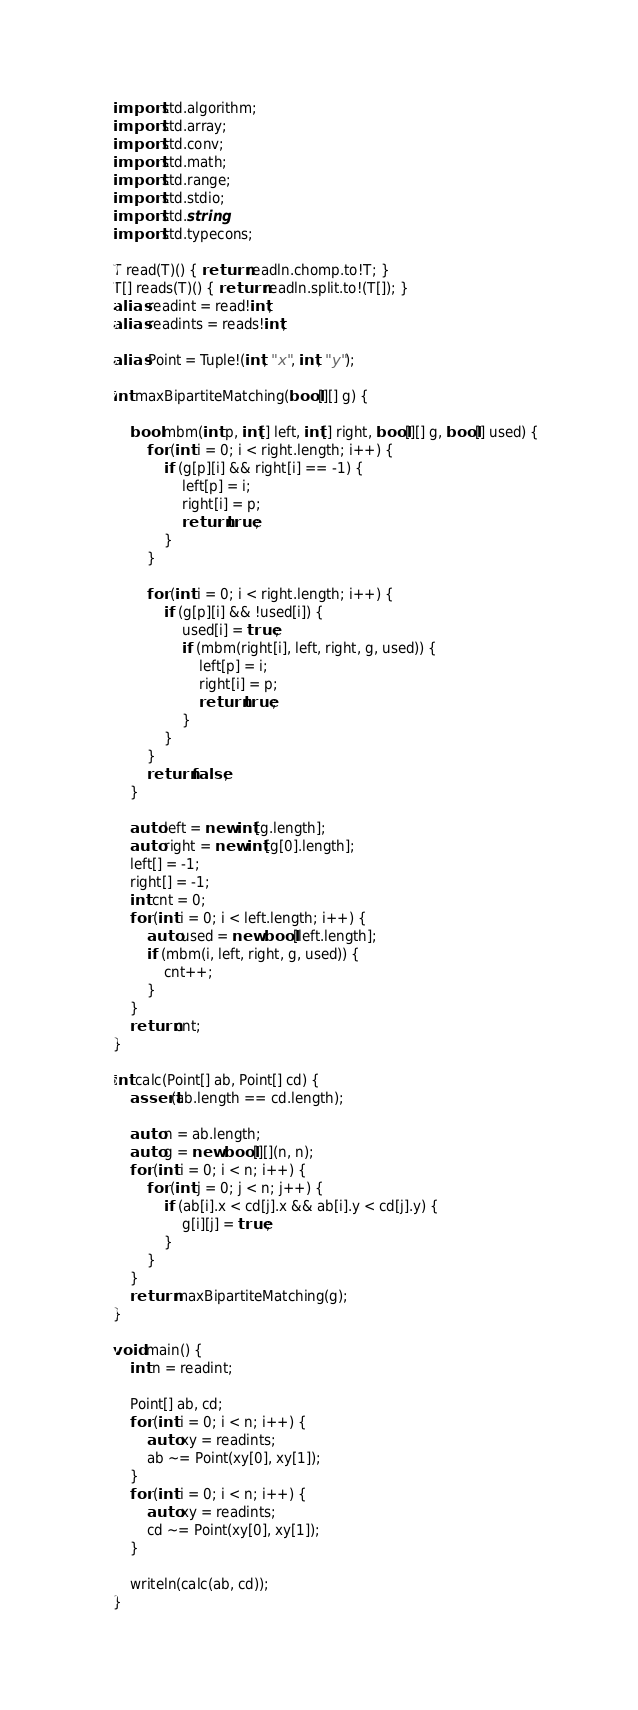Convert code to text. <code><loc_0><loc_0><loc_500><loc_500><_D_>import std.algorithm;
import std.array;
import std.conv;
import std.math;
import std.range;
import std.stdio;
import std.string;
import std.typecons;

T read(T)() { return readln.chomp.to!T; }
T[] reads(T)() { return readln.split.to!(T[]); }
alias readint = read!int;
alias readints = reads!int;

alias Point = Tuple!(int, "x", int, "y");

int maxBipartiteMatching(bool[][] g) {

    bool mbm(int p, int[] left, int[] right, bool[][] g, bool[] used) {
        for (int i = 0; i < right.length; i++) {
            if (g[p][i] && right[i] == -1) {
                left[p] = i;
                right[i] = p;
                return true;
            }
        }

        for (int i = 0; i < right.length; i++) {
            if (g[p][i] && !used[i]) {
                used[i] = true;
                if (mbm(right[i], left, right, g, used)) {
                    left[p] = i;
                    right[i] = p;
                    return true;
                }
            }
        }
        return false;
    }

    auto left = new int[g.length];
    auto right = new int[g[0].length];
    left[] = -1;
    right[] = -1;
    int cnt = 0;
    for (int i = 0; i < left.length; i++) {
        auto used = new bool[left.length];
        if (mbm(i, left, right, g, used)) {
            cnt++;
        }
    }
    return cnt;
}

int calc(Point[] ab, Point[] cd) {
    assert(ab.length == cd.length);

    auto n = ab.length;
    auto g = new bool[][](n, n);
    for (int i = 0; i < n; i++) {
        for (int j = 0; j < n; j++) {
            if (ab[i].x < cd[j].x && ab[i].y < cd[j].y) {
                g[i][j] = true;
            }
        }
    }
    return maxBipartiteMatching(g);
}

void main() {
    int n = readint;

    Point[] ab, cd;
    for (int i = 0; i < n; i++) {
        auto xy = readints;
        ab ~= Point(xy[0], xy[1]);
    }
    for (int i = 0; i < n; i++) {
        auto xy = readints;
        cd ~= Point(xy[0], xy[1]);
    }

    writeln(calc(ab, cd));
}
</code> 